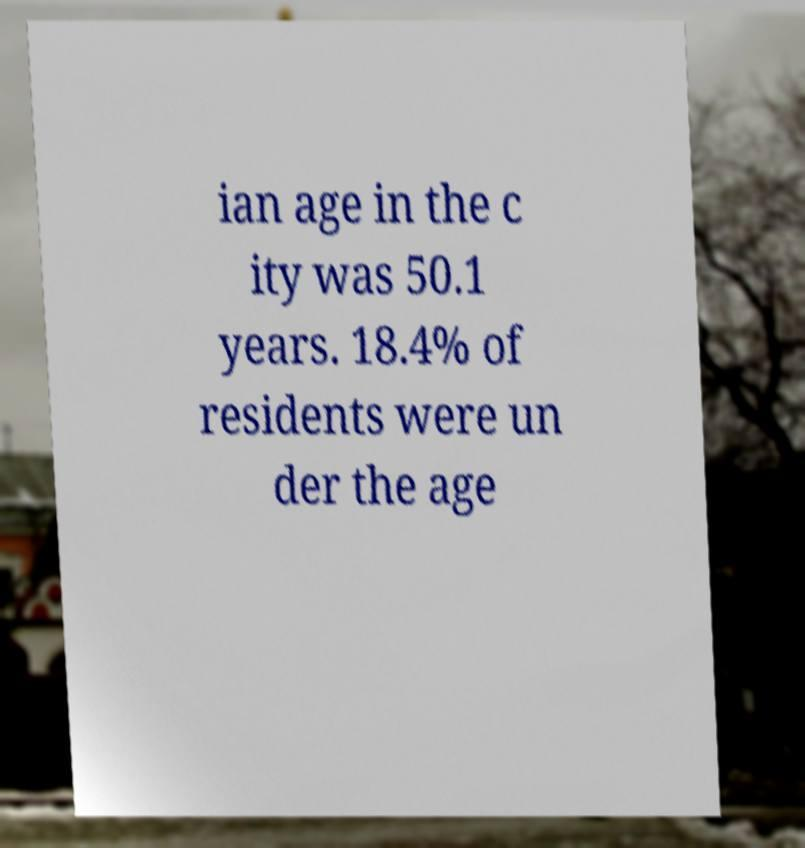Can you read and provide the text displayed in the image?This photo seems to have some interesting text. Can you extract and type it out for me? ian age in the c ity was 50.1 years. 18.4% of residents were un der the age 